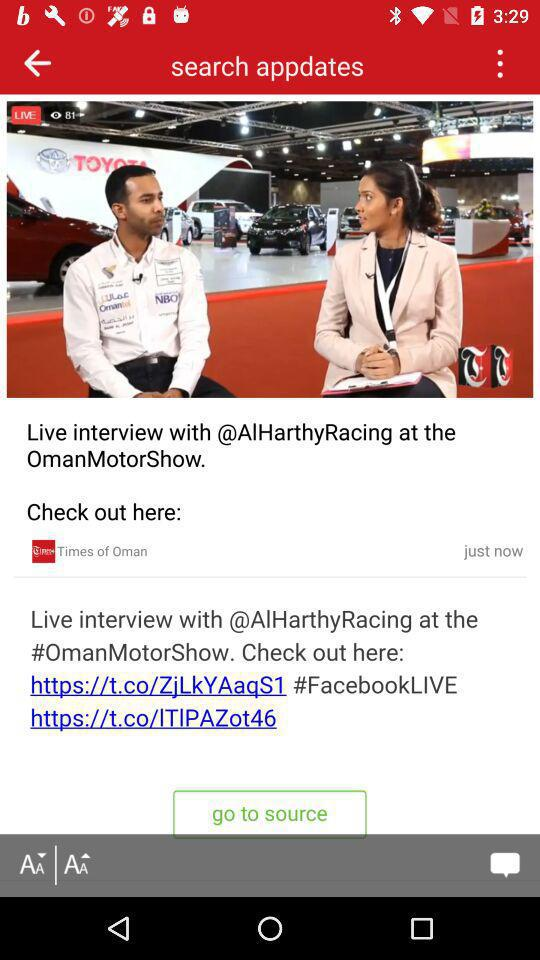What is the number of views? The number of views is 81. 